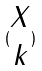Convert formula to latex. <formula><loc_0><loc_0><loc_500><loc_500>( \begin{matrix} X \\ k \end{matrix} )</formula> 